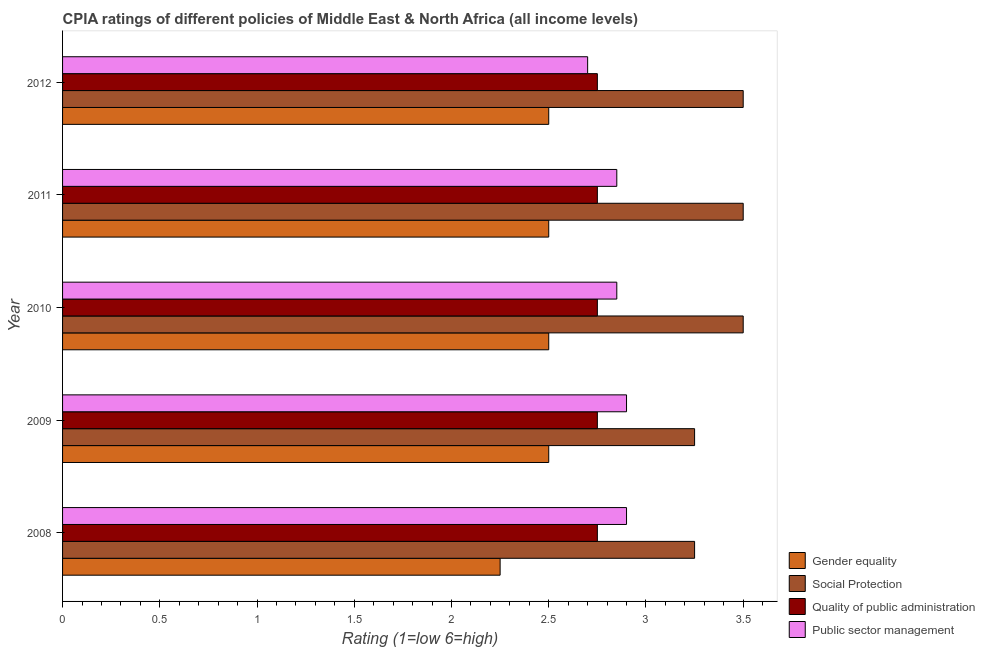How many groups of bars are there?
Keep it short and to the point. 5. Are the number of bars per tick equal to the number of legend labels?
Your answer should be compact. Yes. Are the number of bars on each tick of the Y-axis equal?
Provide a succinct answer. Yes. What is the cpia rating of gender equality in 2012?
Provide a short and direct response. 2.5. Across all years, what is the maximum cpia rating of quality of public administration?
Give a very brief answer. 2.75. Across all years, what is the minimum cpia rating of gender equality?
Offer a terse response. 2.25. In which year was the cpia rating of social protection minimum?
Give a very brief answer. 2008. What is the total cpia rating of quality of public administration in the graph?
Give a very brief answer. 13.75. What is the difference between the cpia rating of quality of public administration in 2010 and the cpia rating of public sector management in 2008?
Keep it short and to the point. -0.15. What is the average cpia rating of gender equality per year?
Offer a very short reply. 2.45. In how many years, is the cpia rating of social protection greater than 1.3 ?
Offer a very short reply. 5. What is the ratio of the cpia rating of quality of public administration in 2008 to that in 2009?
Make the answer very short. 1. Is the cpia rating of public sector management in 2008 less than that in 2010?
Provide a short and direct response. No. Is the difference between the cpia rating of public sector management in 2010 and 2012 greater than the difference between the cpia rating of quality of public administration in 2010 and 2012?
Provide a succinct answer. Yes. What is the difference between the highest and the lowest cpia rating of gender equality?
Offer a terse response. 0.25. In how many years, is the cpia rating of quality of public administration greater than the average cpia rating of quality of public administration taken over all years?
Ensure brevity in your answer.  0. Is the sum of the cpia rating of social protection in 2011 and 2012 greater than the maximum cpia rating of quality of public administration across all years?
Keep it short and to the point. Yes. Is it the case that in every year, the sum of the cpia rating of public sector management and cpia rating of quality of public administration is greater than the sum of cpia rating of social protection and cpia rating of gender equality?
Offer a terse response. No. What does the 3rd bar from the top in 2010 represents?
Provide a succinct answer. Social Protection. What does the 1st bar from the bottom in 2012 represents?
Your answer should be compact. Gender equality. How many bars are there?
Your answer should be compact. 20. How many years are there in the graph?
Provide a short and direct response. 5. Are the values on the major ticks of X-axis written in scientific E-notation?
Your answer should be very brief. No. Does the graph contain any zero values?
Give a very brief answer. No. Does the graph contain grids?
Make the answer very short. No. Where does the legend appear in the graph?
Offer a terse response. Bottom right. How many legend labels are there?
Give a very brief answer. 4. How are the legend labels stacked?
Give a very brief answer. Vertical. What is the title of the graph?
Offer a very short reply. CPIA ratings of different policies of Middle East & North Africa (all income levels). What is the label or title of the X-axis?
Provide a succinct answer. Rating (1=low 6=high). What is the label or title of the Y-axis?
Offer a terse response. Year. What is the Rating (1=low 6=high) in Gender equality in 2008?
Provide a short and direct response. 2.25. What is the Rating (1=low 6=high) in Social Protection in 2008?
Make the answer very short. 3.25. What is the Rating (1=low 6=high) of Quality of public administration in 2008?
Make the answer very short. 2.75. What is the Rating (1=low 6=high) in Public sector management in 2008?
Make the answer very short. 2.9. What is the Rating (1=low 6=high) of Social Protection in 2009?
Offer a terse response. 3.25. What is the Rating (1=low 6=high) of Quality of public administration in 2009?
Provide a short and direct response. 2.75. What is the Rating (1=low 6=high) in Public sector management in 2009?
Give a very brief answer. 2.9. What is the Rating (1=low 6=high) of Social Protection in 2010?
Your answer should be compact. 3.5. What is the Rating (1=low 6=high) in Quality of public administration in 2010?
Offer a very short reply. 2.75. What is the Rating (1=low 6=high) of Public sector management in 2010?
Make the answer very short. 2.85. What is the Rating (1=low 6=high) in Gender equality in 2011?
Offer a terse response. 2.5. What is the Rating (1=low 6=high) of Social Protection in 2011?
Your response must be concise. 3.5. What is the Rating (1=low 6=high) of Quality of public administration in 2011?
Ensure brevity in your answer.  2.75. What is the Rating (1=low 6=high) of Public sector management in 2011?
Keep it short and to the point. 2.85. What is the Rating (1=low 6=high) in Quality of public administration in 2012?
Offer a very short reply. 2.75. Across all years, what is the maximum Rating (1=low 6=high) of Social Protection?
Ensure brevity in your answer.  3.5. Across all years, what is the maximum Rating (1=low 6=high) of Quality of public administration?
Ensure brevity in your answer.  2.75. Across all years, what is the minimum Rating (1=low 6=high) of Gender equality?
Your response must be concise. 2.25. Across all years, what is the minimum Rating (1=low 6=high) in Quality of public administration?
Offer a terse response. 2.75. Across all years, what is the minimum Rating (1=low 6=high) of Public sector management?
Ensure brevity in your answer.  2.7. What is the total Rating (1=low 6=high) in Gender equality in the graph?
Your answer should be very brief. 12.25. What is the total Rating (1=low 6=high) in Quality of public administration in the graph?
Your answer should be compact. 13.75. What is the difference between the Rating (1=low 6=high) in Gender equality in 2008 and that in 2009?
Your answer should be compact. -0.25. What is the difference between the Rating (1=low 6=high) in Social Protection in 2008 and that in 2009?
Give a very brief answer. 0. What is the difference between the Rating (1=low 6=high) of Public sector management in 2008 and that in 2009?
Give a very brief answer. 0. What is the difference between the Rating (1=low 6=high) of Gender equality in 2008 and that in 2010?
Offer a very short reply. -0.25. What is the difference between the Rating (1=low 6=high) of Public sector management in 2008 and that in 2010?
Provide a short and direct response. 0.05. What is the difference between the Rating (1=low 6=high) in Gender equality in 2008 and that in 2011?
Your response must be concise. -0.25. What is the difference between the Rating (1=low 6=high) of Social Protection in 2008 and that in 2011?
Keep it short and to the point. -0.25. What is the difference between the Rating (1=low 6=high) of Gender equality in 2009 and that in 2010?
Provide a succinct answer. 0. What is the difference between the Rating (1=low 6=high) of Gender equality in 2009 and that in 2011?
Your answer should be compact. 0. What is the difference between the Rating (1=low 6=high) of Social Protection in 2009 and that in 2011?
Offer a terse response. -0.25. What is the difference between the Rating (1=low 6=high) of Quality of public administration in 2009 and that in 2011?
Ensure brevity in your answer.  0. What is the difference between the Rating (1=low 6=high) in Gender equality in 2009 and that in 2012?
Offer a very short reply. 0. What is the difference between the Rating (1=low 6=high) in Social Protection in 2009 and that in 2012?
Offer a terse response. -0.25. What is the difference between the Rating (1=low 6=high) in Quality of public administration in 2009 and that in 2012?
Offer a very short reply. 0. What is the difference between the Rating (1=low 6=high) of Gender equality in 2010 and that in 2011?
Offer a terse response. 0. What is the difference between the Rating (1=low 6=high) in Public sector management in 2010 and that in 2011?
Ensure brevity in your answer.  0. What is the difference between the Rating (1=low 6=high) of Gender equality in 2010 and that in 2012?
Give a very brief answer. 0. What is the difference between the Rating (1=low 6=high) in Public sector management in 2010 and that in 2012?
Your response must be concise. 0.15. What is the difference between the Rating (1=low 6=high) of Quality of public administration in 2011 and that in 2012?
Offer a terse response. 0. What is the difference between the Rating (1=low 6=high) in Public sector management in 2011 and that in 2012?
Give a very brief answer. 0.15. What is the difference between the Rating (1=low 6=high) in Gender equality in 2008 and the Rating (1=low 6=high) in Social Protection in 2009?
Give a very brief answer. -1. What is the difference between the Rating (1=low 6=high) in Gender equality in 2008 and the Rating (1=low 6=high) in Quality of public administration in 2009?
Your answer should be very brief. -0.5. What is the difference between the Rating (1=low 6=high) in Gender equality in 2008 and the Rating (1=low 6=high) in Public sector management in 2009?
Provide a succinct answer. -0.65. What is the difference between the Rating (1=low 6=high) of Social Protection in 2008 and the Rating (1=low 6=high) of Public sector management in 2009?
Your answer should be very brief. 0.35. What is the difference between the Rating (1=low 6=high) in Gender equality in 2008 and the Rating (1=low 6=high) in Social Protection in 2010?
Your answer should be very brief. -1.25. What is the difference between the Rating (1=low 6=high) in Quality of public administration in 2008 and the Rating (1=low 6=high) in Public sector management in 2010?
Give a very brief answer. -0.1. What is the difference between the Rating (1=low 6=high) in Gender equality in 2008 and the Rating (1=low 6=high) in Social Protection in 2011?
Your answer should be very brief. -1.25. What is the difference between the Rating (1=low 6=high) in Social Protection in 2008 and the Rating (1=low 6=high) in Quality of public administration in 2011?
Give a very brief answer. 0.5. What is the difference between the Rating (1=low 6=high) of Social Protection in 2008 and the Rating (1=low 6=high) of Public sector management in 2011?
Ensure brevity in your answer.  0.4. What is the difference between the Rating (1=low 6=high) of Quality of public administration in 2008 and the Rating (1=low 6=high) of Public sector management in 2011?
Your response must be concise. -0.1. What is the difference between the Rating (1=low 6=high) of Gender equality in 2008 and the Rating (1=low 6=high) of Social Protection in 2012?
Your response must be concise. -1.25. What is the difference between the Rating (1=low 6=high) in Gender equality in 2008 and the Rating (1=low 6=high) in Quality of public administration in 2012?
Make the answer very short. -0.5. What is the difference between the Rating (1=low 6=high) in Gender equality in 2008 and the Rating (1=low 6=high) in Public sector management in 2012?
Give a very brief answer. -0.45. What is the difference between the Rating (1=low 6=high) in Social Protection in 2008 and the Rating (1=low 6=high) in Public sector management in 2012?
Your response must be concise. 0.55. What is the difference between the Rating (1=low 6=high) of Gender equality in 2009 and the Rating (1=low 6=high) of Quality of public administration in 2010?
Provide a short and direct response. -0.25. What is the difference between the Rating (1=low 6=high) in Gender equality in 2009 and the Rating (1=low 6=high) in Public sector management in 2010?
Provide a short and direct response. -0.35. What is the difference between the Rating (1=low 6=high) of Social Protection in 2009 and the Rating (1=low 6=high) of Quality of public administration in 2010?
Provide a short and direct response. 0.5. What is the difference between the Rating (1=low 6=high) in Social Protection in 2009 and the Rating (1=low 6=high) in Public sector management in 2010?
Make the answer very short. 0.4. What is the difference between the Rating (1=low 6=high) of Quality of public administration in 2009 and the Rating (1=low 6=high) of Public sector management in 2010?
Your answer should be compact. -0.1. What is the difference between the Rating (1=low 6=high) of Gender equality in 2009 and the Rating (1=low 6=high) of Public sector management in 2011?
Provide a short and direct response. -0.35. What is the difference between the Rating (1=low 6=high) in Quality of public administration in 2009 and the Rating (1=low 6=high) in Public sector management in 2011?
Give a very brief answer. -0.1. What is the difference between the Rating (1=low 6=high) in Gender equality in 2009 and the Rating (1=low 6=high) in Social Protection in 2012?
Provide a succinct answer. -1. What is the difference between the Rating (1=low 6=high) of Gender equality in 2009 and the Rating (1=low 6=high) of Quality of public administration in 2012?
Provide a short and direct response. -0.25. What is the difference between the Rating (1=low 6=high) in Social Protection in 2009 and the Rating (1=low 6=high) in Public sector management in 2012?
Offer a very short reply. 0.55. What is the difference between the Rating (1=low 6=high) in Quality of public administration in 2009 and the Rating (1=low 6=high) in Public sector management in 2012?
Provide a succinct answer. 0.05. What is the difference between the Rating (1=low 6=high) in Gender equality in 2010 and the Rating (1=low 6=high) in Social Protection in 2011?
Provide a short and direct response. -1. What is the difference between the Rating (1=low 6=high) of Gender equality in 2010 and the Rating (1=low 6=high) of Quality of public administration in 2011?
Keep it short and to the point. -0.25. What is the difference between the Rating (1=low 6=high) in Gender equality in 2010 and the Rating (1=low 6=high) in Public sector management in 2011?
Provide a succinct answer. -0.35. What is the difference between the Rating (1=low 6=high) in Social Protection in 2010 and the Rating (1=low 6=high) in Public sector management in 2011?
Your answer should be very brief. 0.65. What is the difference between the Rating (1=low 6=high) in Gender equality in 2010 and the Rating (1=low 6=high) in Social Protection in 2012?
Give a very brief answer. -1. What is the difference between the Rating (1=low 6=high) of Gender equality in 2010 and the Rating (1=low 6=high) of Quality of public administration in 2012?
Make the answer very short. -0.25. What is the difference between the Rating (1=low 6=high) in Gender equality in 2010 and the Rating (1=low 6=high) in Public sector management in 2012?
Keep it short and to the point. -0.2. What is the difference between the Rating (1=low 6=high) of Social Protection in 2010 and the Rating (1=low 6=high) of Quality of public administration in 2012?
Offer a terse response. 0.75. What is the difference between the Rating (1=low 6=high) of Social Protection in 2010 and the Rating (1=low 6=high) of Public sector management in 2012?
Give a very brief answer. 0.8. What is the difference between the Rating (1=low 6=high) in Gender equality in 2011 and the Rating (1=low 6=high) in Quality of public administration in 2012?
Ensure brevity in your answer.  -0.25. What is the difference between the Rating (1=low 6=high) of Quality of public administration in 2011 and the Rating (1=low 6=high) of Public sector management in 2012?
Provide a short and direct response. 0.05. What is the average Rating (1=low 6=high) of Gender equality per year?
Your response must be concise. 2.45. What is the average Rating (1=low 6=high) in Quality of public administration per year?
Provide a short and direct response. 2.75. What is the average Rating (1=low 6=high) of Public sector management per year?
Offer a very short reply. 2.84. In the year 2008, what is the difference between the Rating (1=low 6=high) in Gender equality and Rating (1=low 6=high) in Social Protection?
Provide a short and direct response. -1. In the year 2008, what is the difference between the Rating (1=low 6=high) of Gender equality and Rating (1=low 6=high) of Quality of public administration?
Your answer should be very brief. -0.5. In the year 2008, what is the difference between the Rating (1=low 6=high) of Gender equality and Rating (1=low 6=high) of Public sector management?
Ensure brevity in your answer.  -0.65. In the year 2008, what is the difference between the Rating (1=low 6=high) of Social Protection and Rating (1=low 6=high) of Public sector management?
Give a very brief answer. 0.35. In the year 2009, what is the difference between the Rating (1=low 6=high) in Gender equality and Rating (1=low 6=high) in Social Protection?
Offer a very short reply. -0.75. In the year 2009, what is the difference between the Rating (1=low 6=high) of Gender equality and Rating (1=low 6=high) of Quality of public administration?
Offer a terse response. -0.25. In the year 2009, what is the difference between the Rating (1=low 6=high) of Social Protection and Rating (1=low 6=high) of Public sector management?
Provide a succinct answer. 0.35. In the year 2010, what is the difference between the Rating (1=low 6=high) in Gender equality and Rating (1=low 6=high) in Public sector management?
Your answer should be very brief. -0.35. In the year 2010, what is the difference between the Rating (1=low 6=high) of Social Protection and Rating (1=low 6=high) of Quality of public administration?
Give a very brief answer. 0.75. In the year 2010, what is the difference between the Rating (1=low 6=high) of Social Protection and Rating (1=low 6=high) of Public sector management?
Offer a very short reply. 0.65. In the year 2010, what is the difference between the Rating (1=low 6=high) in Quality of public administration and Rating (1=low 6=high) in Public sector management?
Your answer should be compact. -0.1. In the year 2011, what is the difference between the Rating (1=low 6=high) of Gender equality and Rating (1=low 6=high) of Public sector management?
Ensure brevity in your answer.  -0.35. In the year 2011, what is the difference between the Rating (1=low 6=high) of Social Protection and Rating (1=low 6=high) of Public sector management?
Your answer should be compact. 0.65. In the year 2012, what is the difference between the Rating (1=low 6=high) of Gender equality and Rating (1=low 6=high) of Social Protection?
Your response must be concise. -1. In the year 2012, what is the difference between the Rating (1=low 6=high) in Quality of public administration and Rating (1=low 6=high) in Public sector management?
Offer a terse response. 0.05. What is the ratio of the Rating (1=low 6=high) of Gender equality in 2008 to that in 2009?
Offer a terse response. 0.9. What is the ratio of the Rating (1=low 6=high) in Quality of public administration in 2008 to that in 2009?
Your answer should be compact. 1. What is the ratio of the Rating (1=low 6=high) in Gender equality in 2008 to that in 2010?
Offer a terse response. 0.9. What is the ratio of the Rating (1=low 6=high) in Social Protection in 2008 to that in 2010?
Make the answer very short. 0.93. What is the ratio of the Rating (1=low 6=high) of Public sector management in 2008 to that in 2010?
Your response must be concise. 1.02. What is the ratio of the Rating (1=low 6=high) in Quality of public administration in 2008 to that in 2011?
Your answer should be very brief. 1. What is the ratio of the Rating (1=low 6=high) in Public sector management in 2008 to that in 2011?
Give a very brief answer. 1.02. What is the ratio of the Rating (1=low 6=high) in Gender equality in 2008 to that in 2012?
Your response must be concise. 0.9. What is the ratio of the Rating (1=low 6=high) in Public sector management in 2008 to that in 2012?
Keep it short and to the point. 1.07. What is the ratio of the Rating (1=low 6=high) in Public sector management in 2009 to that in 2010?
Offer a terse response. 1.02. What is the ratio of the Rating (1=low 6=high) of Social Protection in 2009 to that in 2011?
Make the answer very short. 0.93. What is the ratio of the Rating (1=low 6=high) of Public sector management in 2009 to that in 2011?
Provide a succinct answer. 1.02. What is the ratio of the Rating (1=low 6=high) of Gender equality in 2009 to that in 2012?
Make the answer very short. 1. What is the ratio of the Rating (1=low 6=high) of Social Protection in 2009 to that in 2012?
Your response must be concise. 0.93. What is the ratio of the Rating (1=low 6=high) of Quality of public administration in 2009 to that in 2012?
Keep it short and to the point. 1. What is the ratio of the Rating (1=low 6=high) of Public sector management in 2009 to that in 2012?
Offer a very short reply. 1.07. What is the ratio of the Rating (1=low 6=high) in Gender equality in 2010 to that in 2011?
Provide a succinct answer. 1. What is the ratio of the Rating (1=low 6=high) of Social Protection in 2010 to that in 2011?
Offer a terse response. 1. What is the ratio of the Rating (1=low 6=high) in Quality of public administration in 2010 to that in 2011?
Make the answer very short. 1. What is the ratio of the Rating (1=low 6=high) in Gender equality in 2010 to that in 2012?
Provide a succinct answer. 1. What is the ratio of the Rating (1=low 6=high) in Quality of public administration in 2010 to that in 2012?
Your response must be concise. 1. What is the ratio of the Rating (1=low 6=high) in Public sector management in 2010 to that in 2012?
Ensure brevity in your answer.  1.06. What is the ratio of the Rating (1=low 6=high) of Gender equality in 2011 to that in 2012?
Provide a short and direct response. 1. What is the ratio of the Rating (1=low 6=high) in Social Protection in 2011 to that in 2012?
Give a very brief answer. 1. What is the ratio of the Rating (1=low 6=high) in Public sector management in 2011 to that in 2012?
Your response must be concise. 1.06. What is the difference between the highest and the second highest Rating (1=low 6=high) of Social Protection?
Your response must be concise. 0. What is the difference between the highest and the second highest Rating (1=low 6=high) of Quality of public administration?
Provide a succinct answer. 0. What is the difference between the highest and the second highest Rating (1=low 6=high) of Public sector management?
Offer a terse response. 0. What is the difference between the highest and the lowest Rating (1=low 6=high) in Gender equality?
Keep it short and to the point. 0.25. 